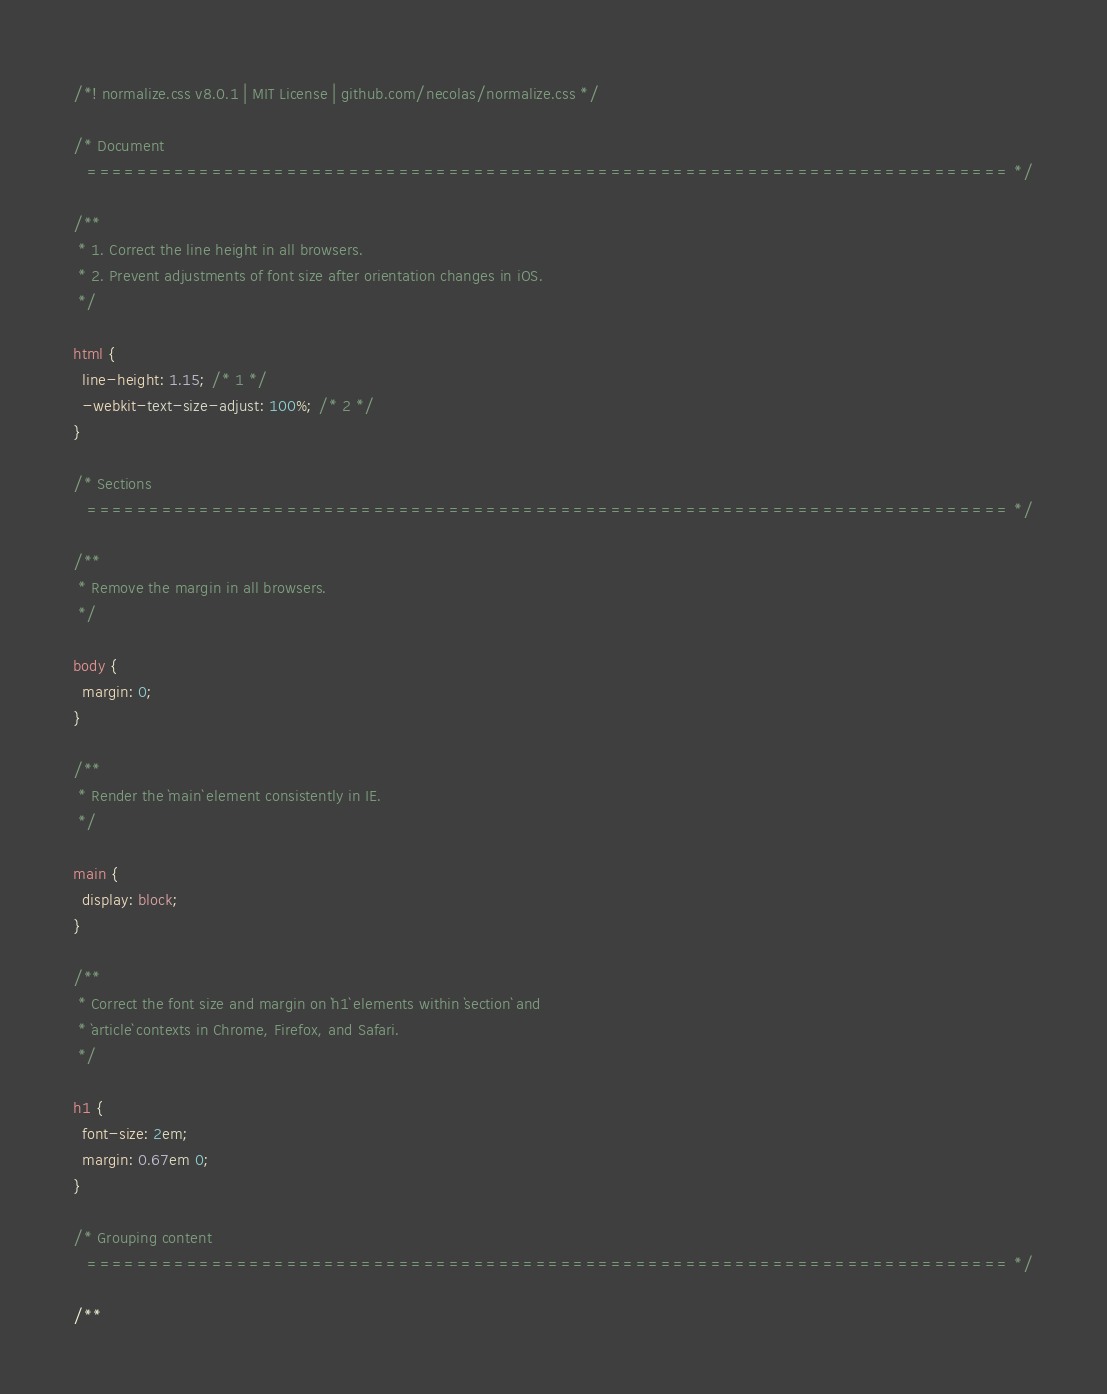Convert code to text. <code><loc_0><loc_0><loc_500><loc_500><_CSS_>/*! normalize.css v8.0.1 | MIT License | github.com/necolas/normalize.css */

/* Document
   ========================================================================== */

/**
 * 1. Correct the line height in all browsers.
 * 2. Prevent adjustments of font size after orientation changes in iOS.
 */

html {
  line-height: 1.15; /* 1 */
  -webkit-text-size-adjust: 100%; /* 2 */
}

/* Sections
   ========================================================================== */

/**
 * Remove the margin in all browsers.
 */

body {
  margin: 0;
}

/**
 * Render the `main` element consistently in IE.
 */

main {
  display: block;
}

/**
 * Correct the font size and margin on `h1` elements within `section` and
 * `article` contexts in Chrome, Firefox, and Safari.
 */

h1 {
  font-size: 2em;
  margin: 0.67em 0;
}

/* Grouping content
   ========================================================================== */

/**</code> 